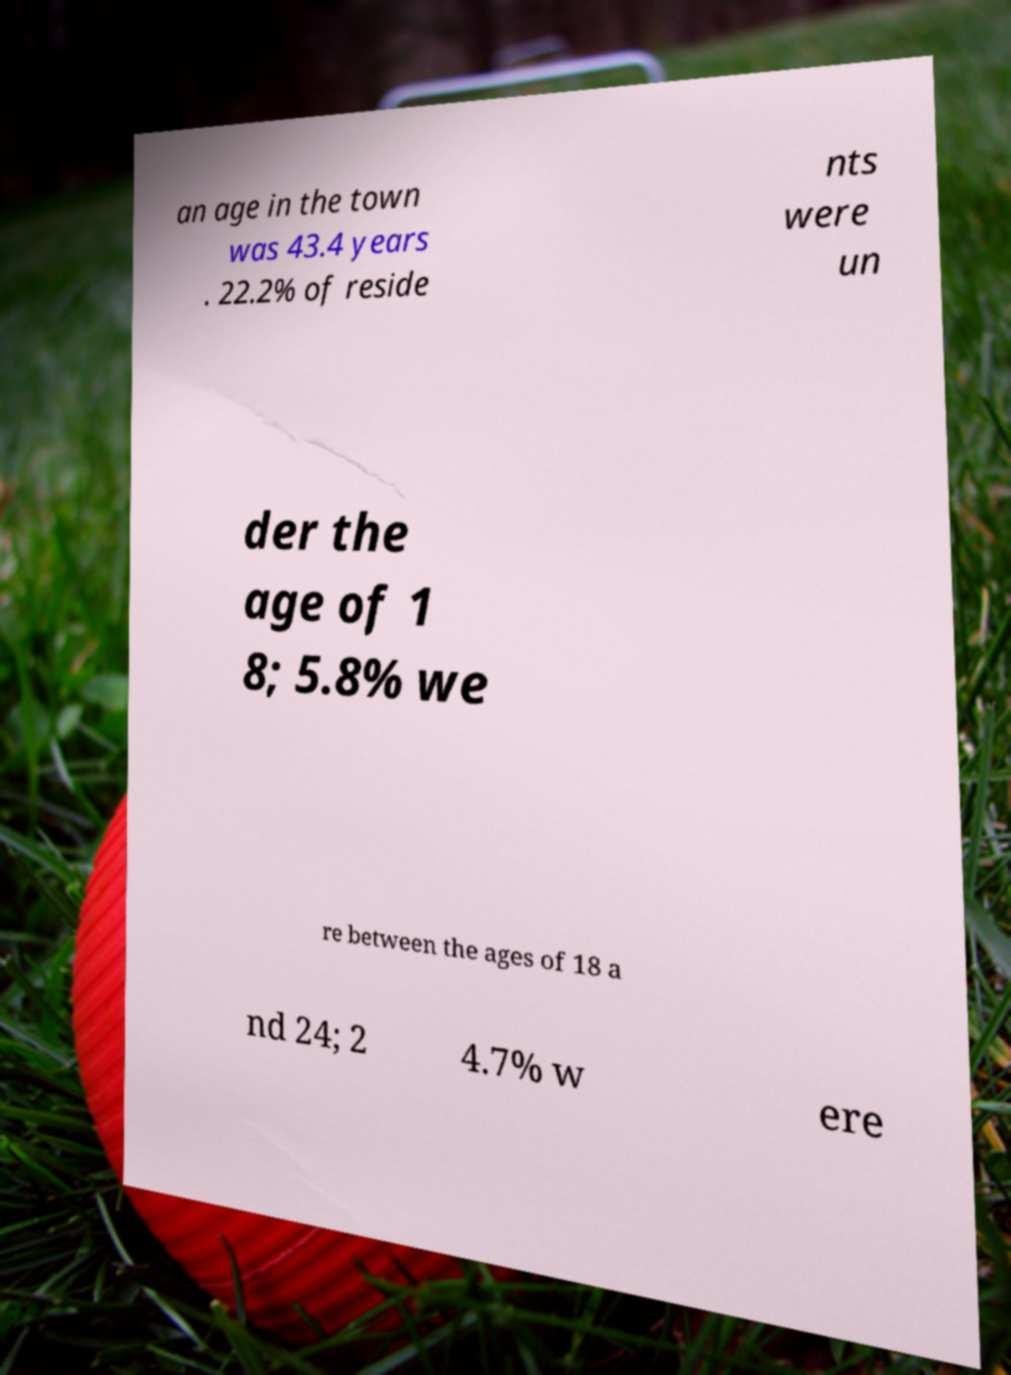Please read and relay the text visible in this image. What does it say? an age in the town was 43.4 years . 22.2% of reside nts were un der the age of 1 8; 5.8% we re between the ages of 18 a nd 24; 2 4.7% w ere 